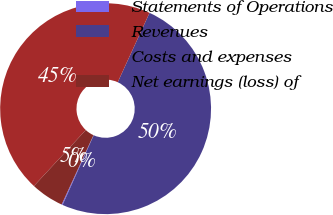Convert chart to OTSL. <chart><loc_0><loc_0><loc_500><loc_500><pie_chart><fcel>Statements of Operations<fcel>Revenues<fcel>Costs and expenses<fcel>Net earnings (loss) of<nl><fcel>0.15%<fcel>49.85%<fcel>44.94%<fcel>5.06%<nl></chart> 